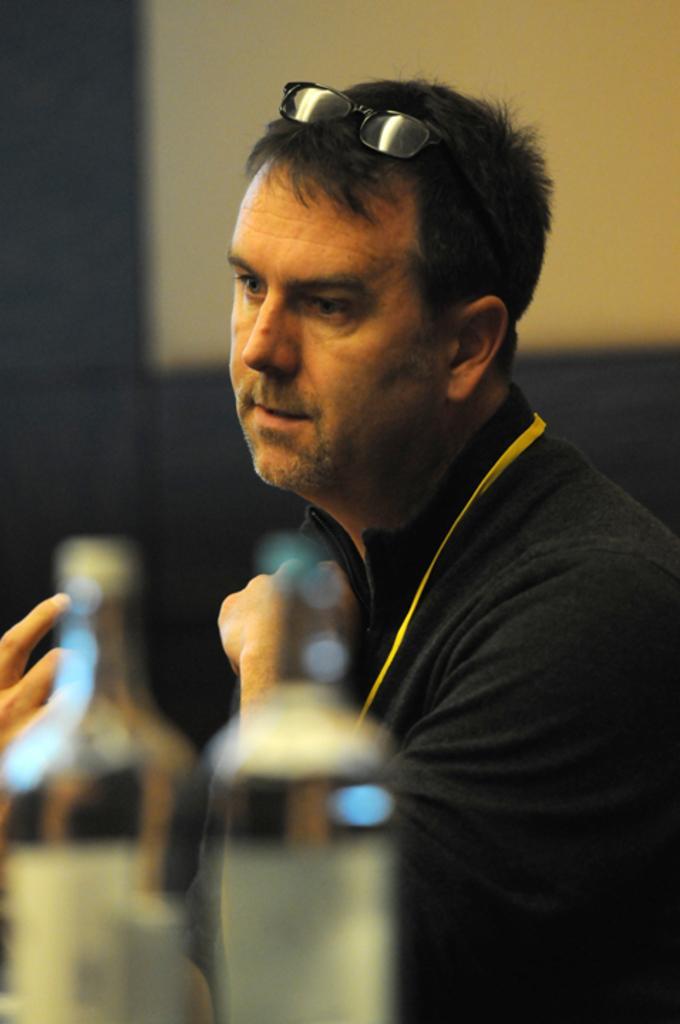Can you describe this image briefly? There is a person with a specs on the head. There are bottles and it is looking blurred. In the background it is blurred. 